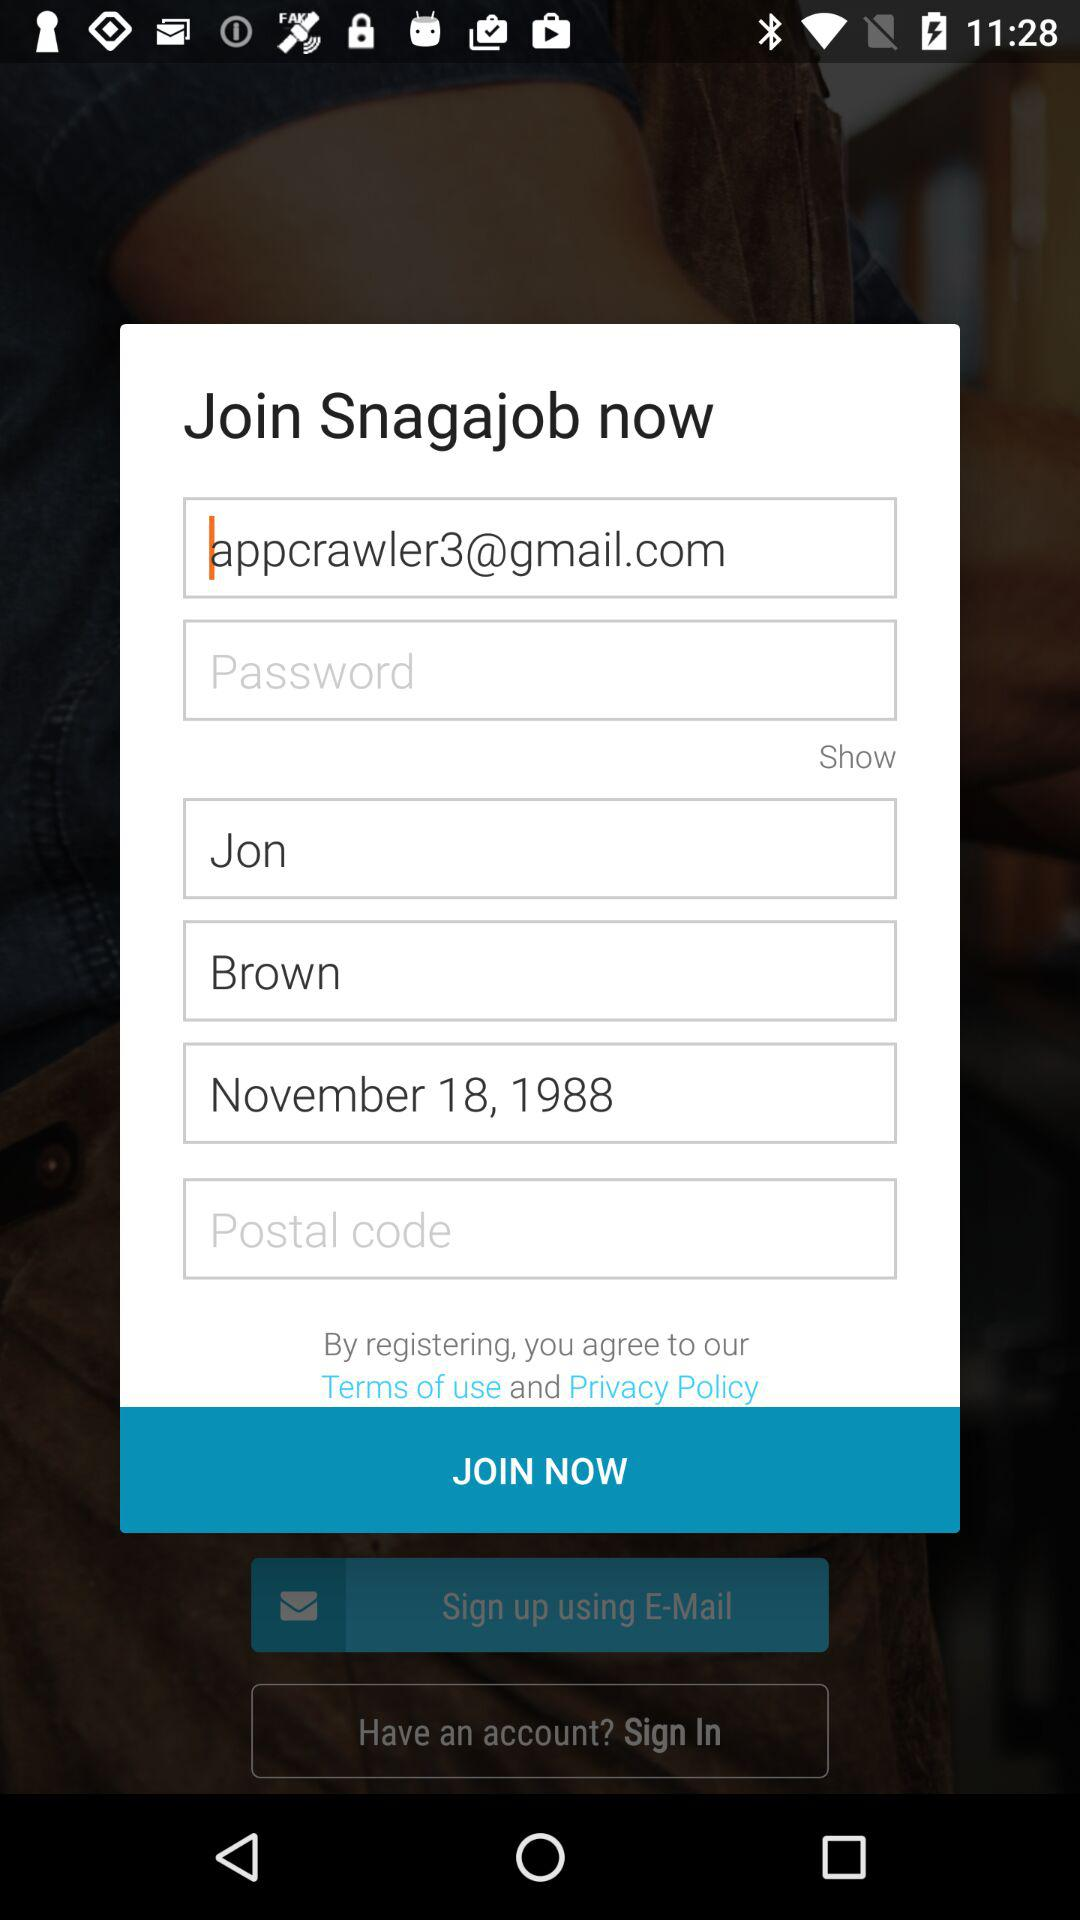What is the user name? The user name is Jon Brown. 